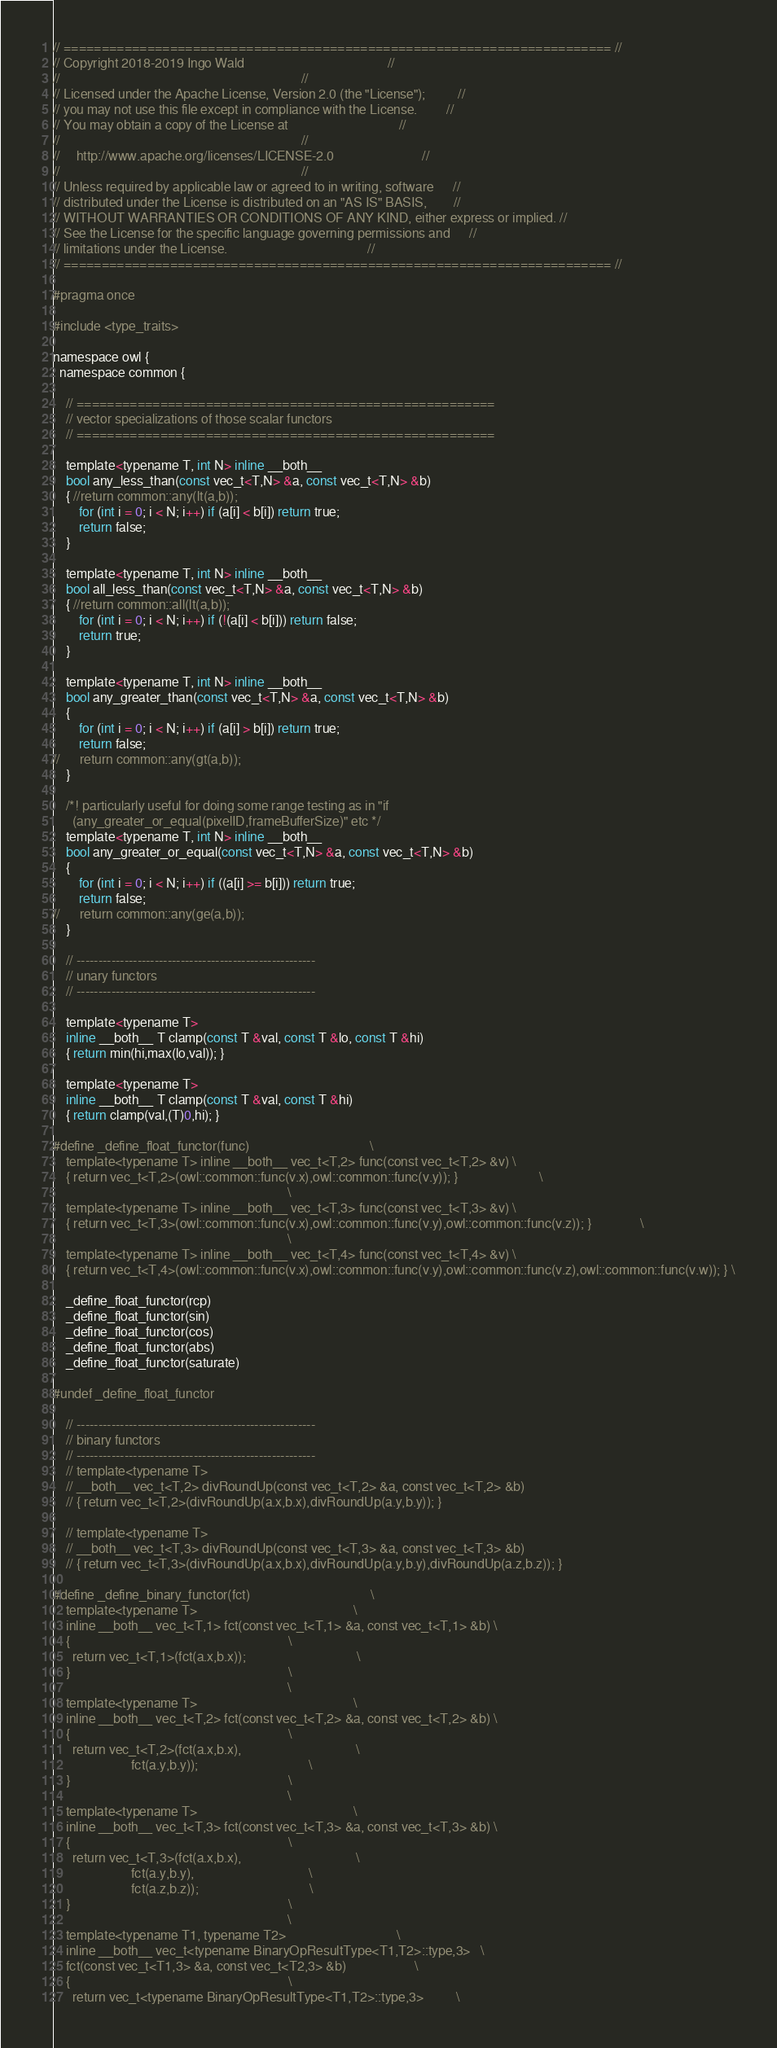<code> <loc_0><loc_0><loc_500><loc_500><_C_>// ======================================================================== //
// Copyright 2018-2019 Ingo Wald                                            //
//                                                                          //
// Licensed under the Apache License, Version 2.0 (the "License");          //
// you may not use this file except in compliance with the License.         //
// You may obtain a copy of the License at                                  //
//                                                                          //
//     http://www.apache.org/licenses/LICENSE-2.0                           //
//                                                                          //
// Unless required by applicable law or agreed to in writing, software      //
// distributed under the License is distributed on an "AS IS" BASIS,        //
// WITHOUT WARRANTIES OR CONDITIONS OF ANY KIND, either express or implied. //
// See the License for the specific language governing permissions and      //
// limitations under the License.                                           //
// ======================================================================== //

#pragma once

#include <type_traits>

namespace owl {
  namespace common {

    // =======================================================
    // vector specializations of those scalar functors
    // =======================================================

    template<typename T, int N> inline __both__
    bool any_less_than(const vec_t<T,N> &a, const vec_t<T,N> &b)
    { //return common::any(lt(a,b)); 
		for (int i = 0; i < N; i++) if (a[i] < b[i]) return true;
		return false;
	}
  
    template<typename T, int N> inline __both__
    bool all_less_than(const vec_t<T,N> &a, const vec_t<T,N> &b)
    { //return common::all(lt(a,b)); 
		for (int i = 0; i < N; i++) if (!(a[i] < b[i])) return false;
		return true;
	}
  
    template<typename T, int N> inline __both__
    bool any_greater_than(const vec_t<T,N> &a, const vec_t<T,N> &b)
    { 
		for (int i = 0; i < N; i++) if (a[i] > b[i]) return true;
		return false;
//		return common::any(gt(a,b)); 
	}

    /*! particularly useful for doing some range testing as in "if
      (any_greater_or_equal(pixelID,frameBufferSize)" etc */
    template<typename T, int N> inline __both__
    bool any_greater_or_equal(const vec_t<T,N> &a, const vec_t<T,N> &b)
    { 
		for (int i = 0; i < N; i++) if ((a[i] >= b[i])) return true;
		return false;
//		return common::any(ge(a,b)); 
	}

    // -------------------------------------------------------
    // unary functors
    // -------------------------------------------------------

    template<typename T>
    inline __both__ T clamp(const T &val, const T &lo, const T &hi)
    { return min(hi,max(lo,val)); }
  
    template<typename T>
    inline __both__ T clamp(const T &val, const T &hi)
    { return clamp(val,(T)0,hi); }
  
#define _define_float_functor(func)                                     \
    template<typename T> inline __both__ vec_t<T,2> func(const vec_t<T,2> &v) \
    { return vec_t<T,2>(owl::common::func(v.x),owl::common::func(v.y)); }                         \
                                                                        \
    template<typename T> inline __both__ vec_t<T,3> func(const vec_t<T,3> &v) \
    { return vec_t<T,3>(owl::common::func(v.x),owl::common::func(v.y),owl::common::func(v.z)); }               \
                                                                        \
    template<typename T> inline __both__ vec_t<T,4> func(const vec_t<T,4> &v) \
    { return vec_t<T,4>(owl::common::func(v.x),owl::common::func(v.y),owl::common::func(v.z),owl::common::func(v.w)); } \

    _define_float_functor(rcp)
    _define_float_functor(sin)
    _define_float_functor(cos)
    _define_float_functor(abs)
    _define_float_functor(saturate)
  
#undef _define_float_functor
  
    // -------------------------------------------------------
    // binary functors
    // -------------------------------------------------------
    // template<typename T>
    // __both__ vec_t<T,2> divRoundUp(const vec_t<T,2> &a, const vec_t<T,2> &b)
    // { return vec_t<T,2>(divRoundUp(a.x,b.x),divRoundUp(a.y,b.y)); }
  
    // template<typename T>
    // __both__ vec_t<T,3> divRoundUp(const vec_t<T,3> &a, const vec_t<T,3> &b)
    // { return vec_t<T,3>(divRoundUp(a.x,b.x),divRoundUp(a.y,b.y),divRoundUp(a.z,b.z)); }

#define _define_binary_functor(fct)                                     \
    template<typename T>                                                \
    inline __both__ vec_t<T,1> fct(const vec_t<T,1> &a, const vec_t<T,1> &b) \
    {                                                                   \
      return vec_t<T,1>(fct(a.x,b.x));                                  \
    }                                                                   \
                                                                        \
    template<typename T>                                                \
    inline __both__ vec_t<T,2> fct(const vec_t<T,2> &a, const vec_t<T,2> &b) \
    {                                                                   \
      return vec_t<T,2>(fct(a.x,b.x),                                   \
                        fct(a.y,b.y));                                  \
    }                                                                   \
                                                                        \
    template<typename T>                                                \
    inline __both__ vec_t<T,3> fct(const vec_t<T,3> &a, const vec_t<T,3> &b) \
    {                                                                   \
      return vec_t<T,3>(fct(a.x,b.x),                                   \
                        fct(a.y,b.y),                                   \
                        fct(a.z,b.z));                                  \
    }                                                                   \
                                                                        \
    template<typename T1, typename T2>                                  \
    inline __both__ vec_t<typename BinaryOpResultType<T1,T2>::type,3>   \
    fct(const vec_t<T1,3> &a, const vec_t<T2,3> &b)                     \
    {                                                                   \
      return vec_t<typename BinaryOpResultType<T1,T2>::type,3>          \</code> 